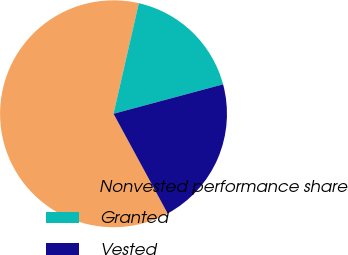<chart> <loc_0><loc_0><loc_500><loc_500><pie_chart><fcel>Nonvested performance share<fcel>Granted<fcel>Vested<nl><fcel>61.49%<fcel>17.24%<fcel>21.26%<nl></chart> 